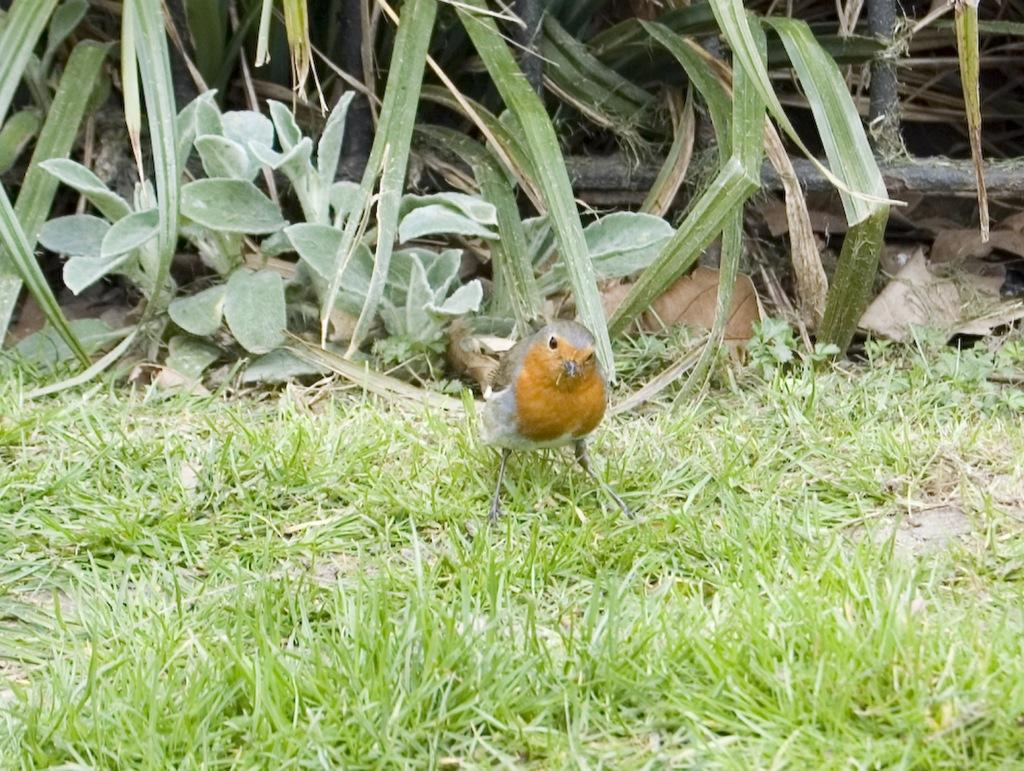What is the bird doing in the image? The bird is standing on the grass in the image. What type of vegetation can be seen in the image? There are plants visible in the image. What type of scarf is the bird wearing in the image? There is no scarf present in the image; the bird is not wearing any clothing. 